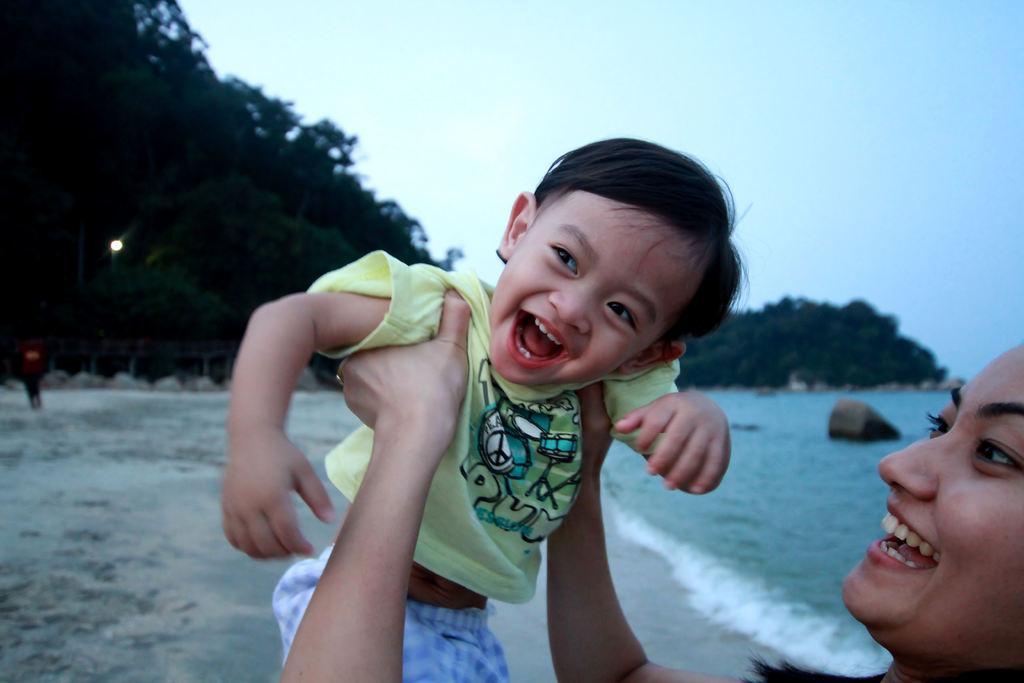Describe this image in one or two sentences. In this image, we can see a woman is holding a kid. They both are smiling. Background we can see the water, sand, trees, light and sky. On the left side of the image, we can see a person. 